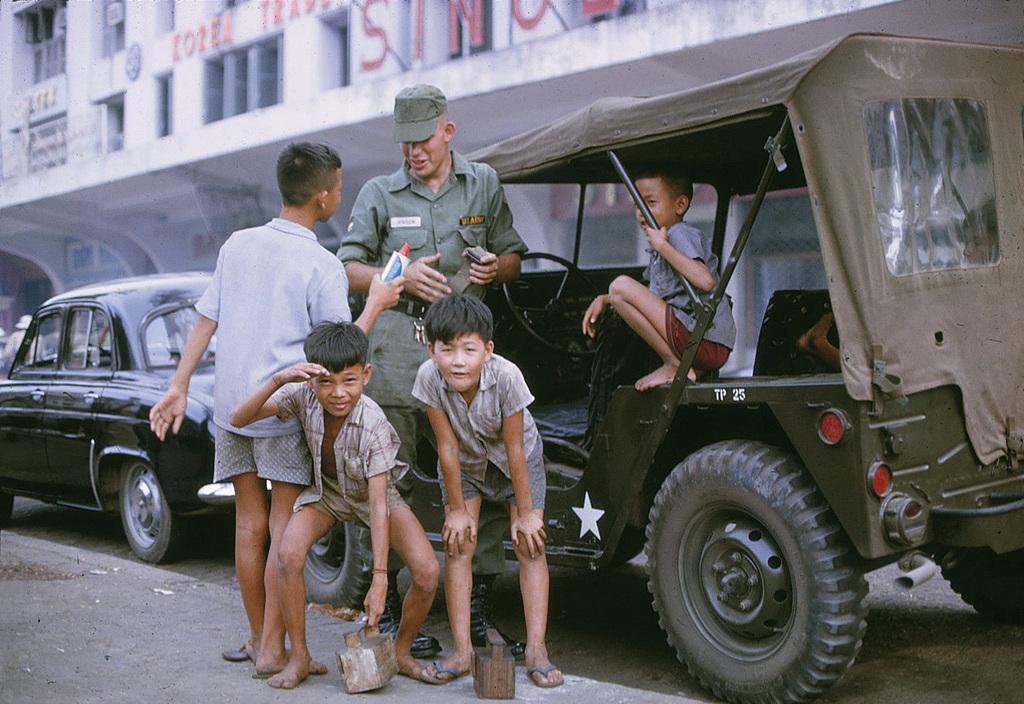How would you summarize this image in a sentence or two? In this image we can see few persons in the foreground and among few people are holding objects. Behind the persons we can see vehicles and a building. On the building we can see some text. On the left side, we can see a person. 